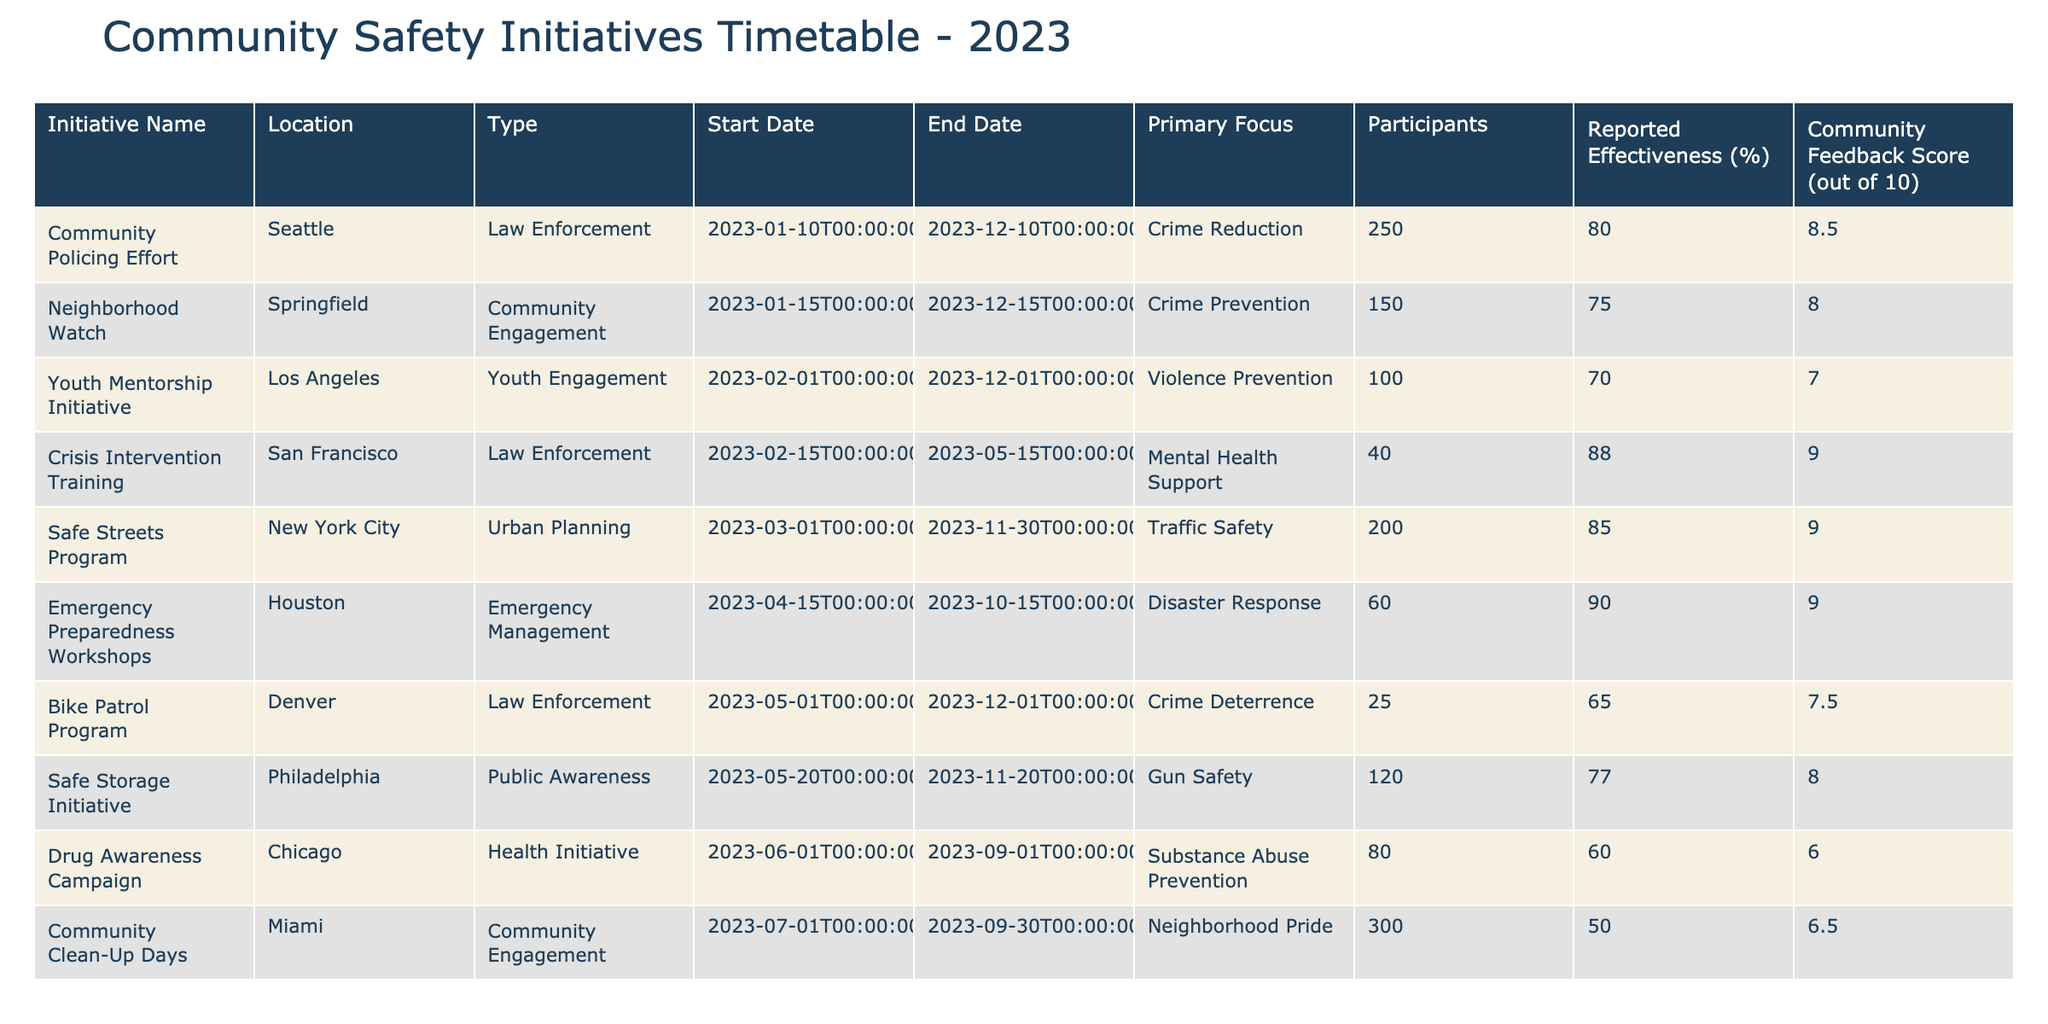What is the primary focus of the Youth Mentorship Initiative? The table lists the primary focus for the Youth Mentorship Initiative under the "Primary Focus" column. It is stated as "Violence Prevention."
Answer: Violence Prevention Which initiative has the highest reported effectiveness percentage? By comparing the "Reported Effectiveness (%)" column, the "Emergency Preparedness Workshops" has the highest value at 90%.
Answer: Emergency Preparedness Workshops True or false: The Community Clean-Up Days initiative has a community feedback score of 8. The table indicates that the Community Clean-Up Days initiative has a feedback score of 6.5, which makes the statement false.
Answer: False What is the average community feedback score for all initiatives listed? To find the average community feedback score, sum the scores: (8 + 9 + 7 + 8.5 + 6 + 9 + 7.5 + 6.5 + 8) = 70.5. There are 9 initiatives, so the average is 70.5 / 9 = 7.833.
Answer: 7.83 Which two initiatives focus on crime prevention? Reviewing the "Primary Focus" column, the Neighborhood Watch focuses on "Crime Prevention," and the Community Policing Effort also focuses on "Crime Reduction," which is related to crime prevention.
Answer: Neighborhood Watch, Community Policing Effort How many participants are involved in the Safe Streets Program and the Emergency Preparedness Workshops combined? The Safe Streets Program has 200 participants and the Emergency Preparedness Workshops have 60 participants. Adding them together: 200 + 60 = 260 participants.
Answer: 260 Which initiative is focused on gun safety and where is it located? By checking the "Primary Focus" and "Location" columns, the initiative focused on "Gun Safety" is the Safe Storage Initiative located in Philadelphia.
Answer: Safe Storage Initiative, Philadelphia Is there any initiative with a reported effectiveness below 70%? Checking the "Reported Effectiveness (%)" column, both the Youth Mentorship Initiative (70%) and the Drug Awareness Campaign (60%) fall below 70%, confirming that such initiatives exist.
Answer: Yes What is the difference in reported effectiveness between the Crisis Intervention Training and the Drug Awareness Campaign? The Crisis Intervention Training has an effectiveness of 88% and the Drug Awareness Campaign has 60%. The difference can be calculated as 88 - 60 = 28%.
Answer: 28% 